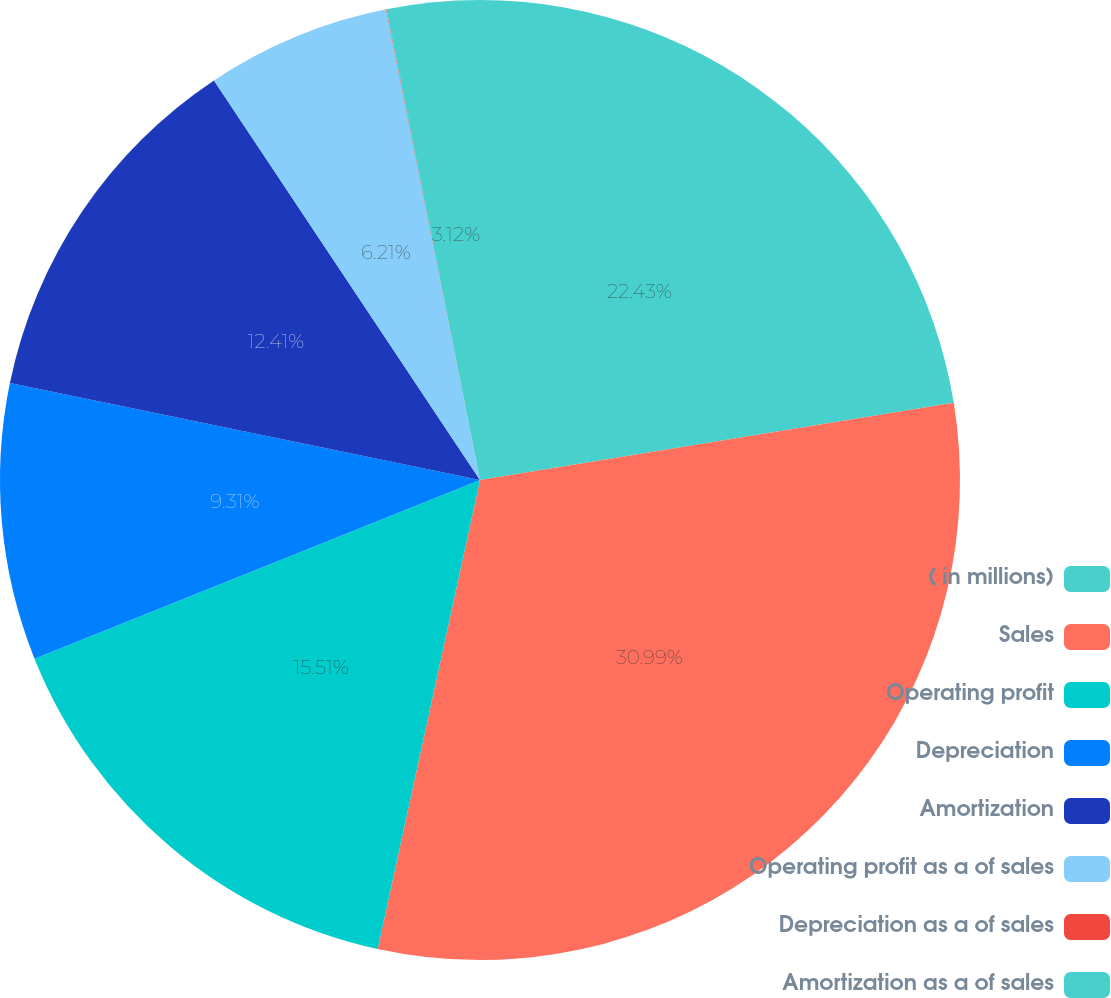Convert chart. <chart><loc_0><loc_0><loc_500><loc_500><pie_chart><fcel>( in millions)<fcel>Sales<fcel>Operating profit<fcel>Depreciation<fcel>Amortization<fcel>Operating profit as a of sales<fcel>Depreciation as a of sales<fcel>Amortization as a of sales<nl><fcel>22.43%<fcel>30.99%<fcel>15.51%<fcel>9.31%<fcel>12.41%<fcel>6.21%<fcel>0.02%<fcel>3.12%<nl></chart> 